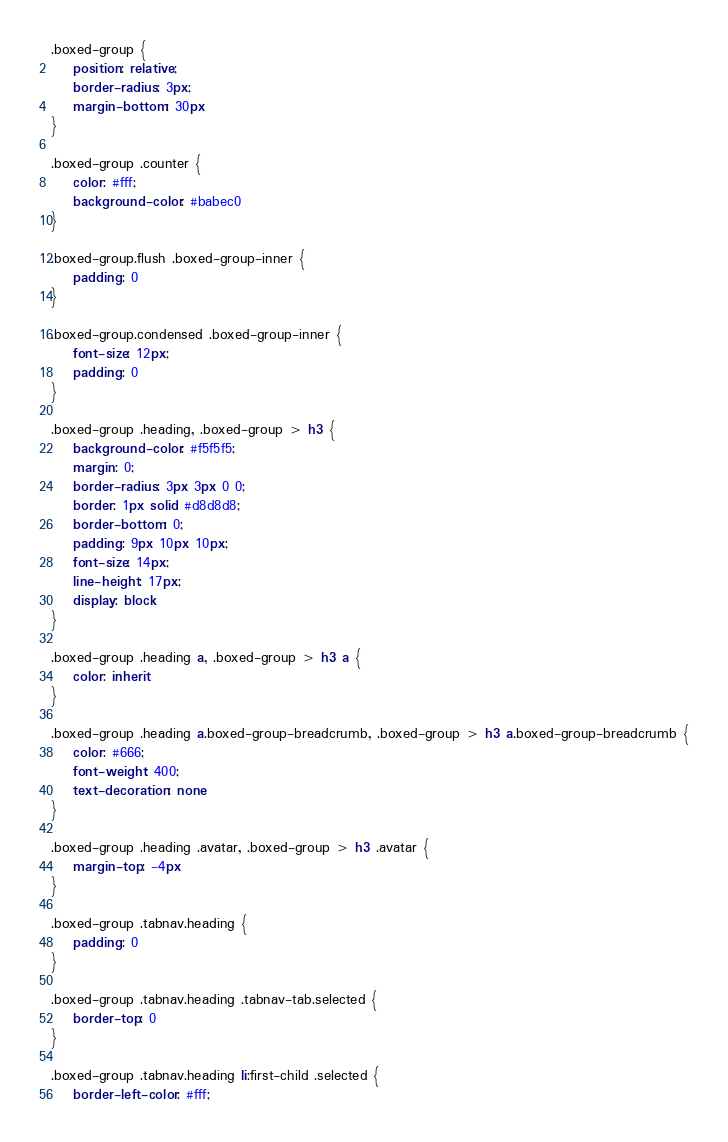Convert code to text. <code><loc_0><loc_0><loc_500><loc_500><_CSS_>.boxed-group {
    position: relative;
    border-radius: 3px;
    margin-bottom: 30px
}

.boxed-group .counter {
    color: #fff;
    background-color: #babec0
}

.boxed-group.flush .boxed-group-inner {
    padding: 0
}

.boxed-group.condensed .boxed-group-inner {
    font-size: 12px;
    padding: 0
}

.boxed-group .heading, .boxed-group > h3 {
    background-color: #f5f5f5;
    margin: 0;
    border-radius: 3px 3px 0 0;
    border: 1px solid #d8d8d8;
    border-bottom: 0;
    padding: 9px 10px 10px;
    font-size: 14px;
    line-height: 17px;
    display: block
}

.boxed-group .heading a, .boxed-group > h3 a {
    color: inherit
}

.boxed-group .heading a.boxed-group-breadcrumb, .boxed-group > h3 a.boxed-group-breadcrumb {
    color: #666;
    font-weight: 400;
    text-decoration: none
}

.boxed-group .heading .avatar, .boxed-group > h3 .avatar {
    margin-top: -4px
}

.boxed-group .tabnav.heading {
    padding: 0
}

.boxed-group .tabnav.heading .tabnav-tab.selected {
    border-top: 0
}

.boxed-group .tabnav.heading li:first-child .selected {
    border-left-color: #fff;</code> 